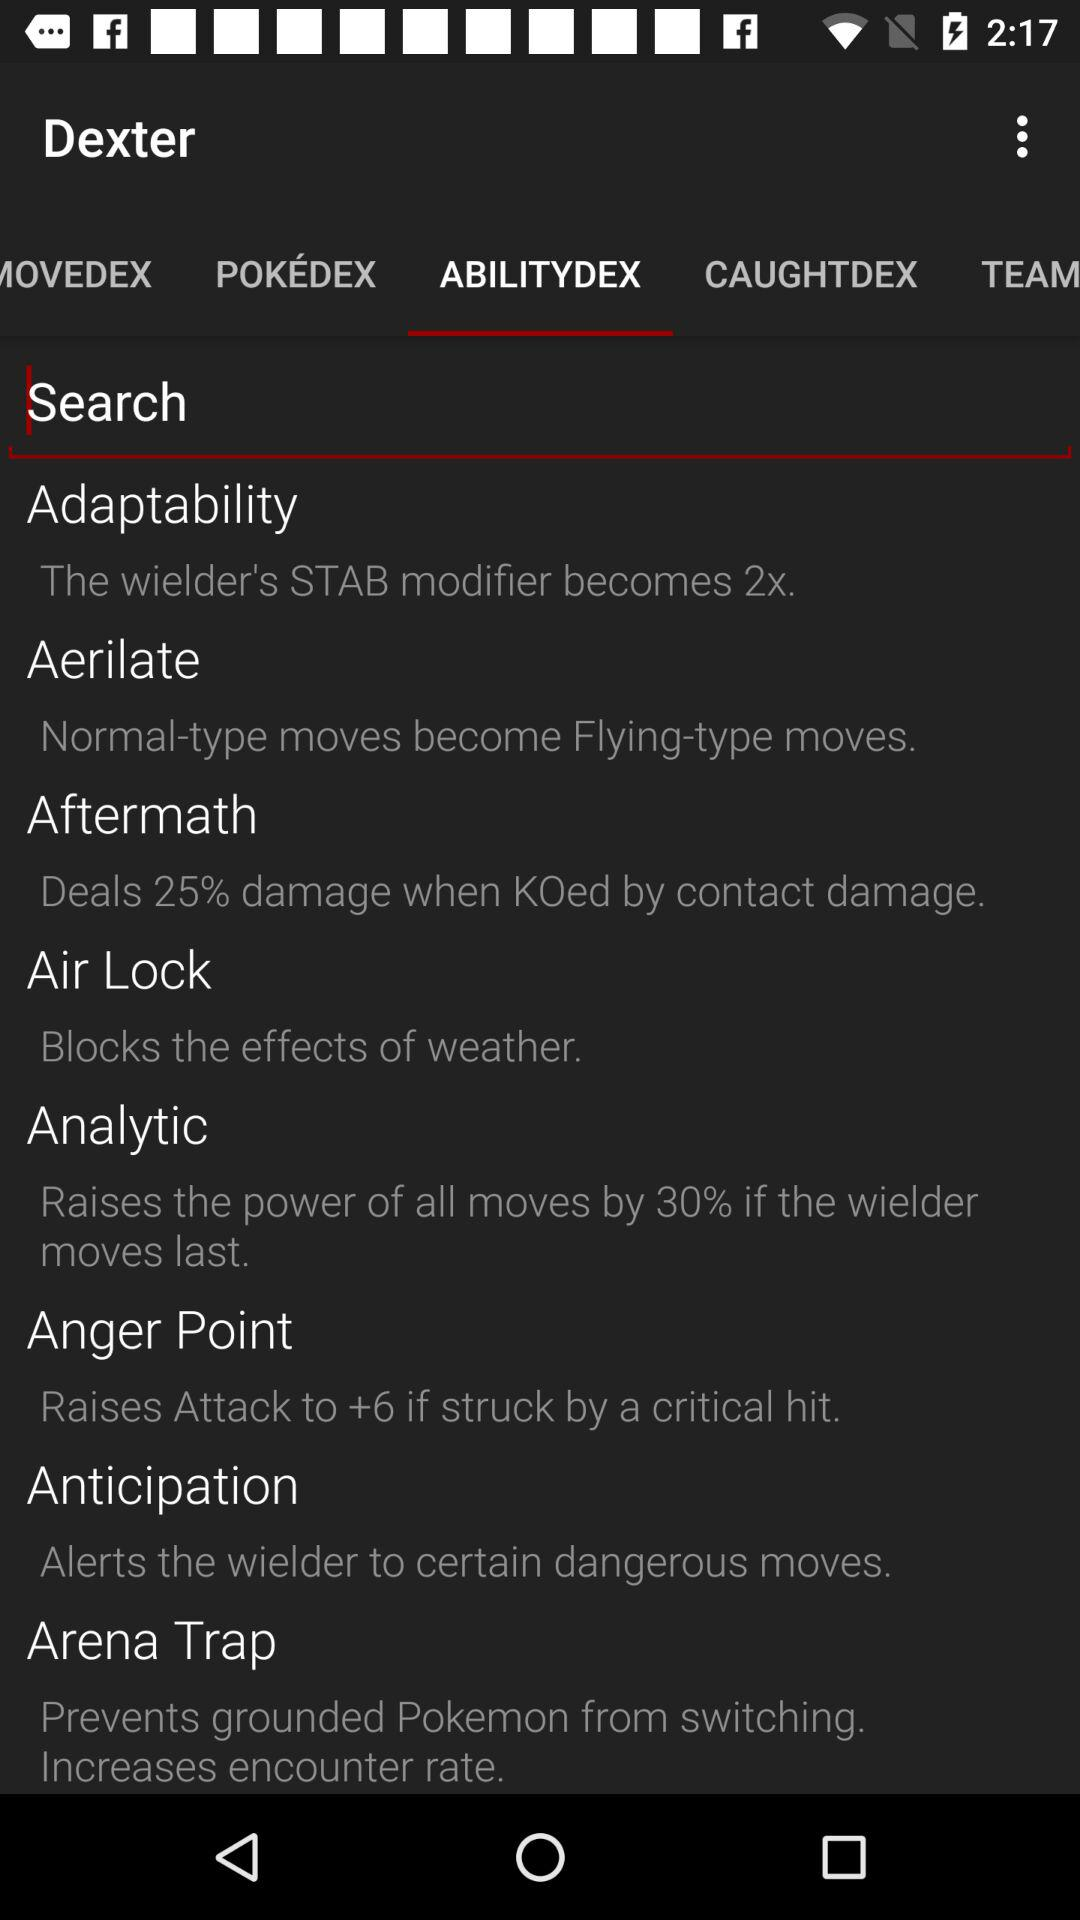What is the selected option in Dexter? The selected option in Dexter is "ABILITYDEX". 